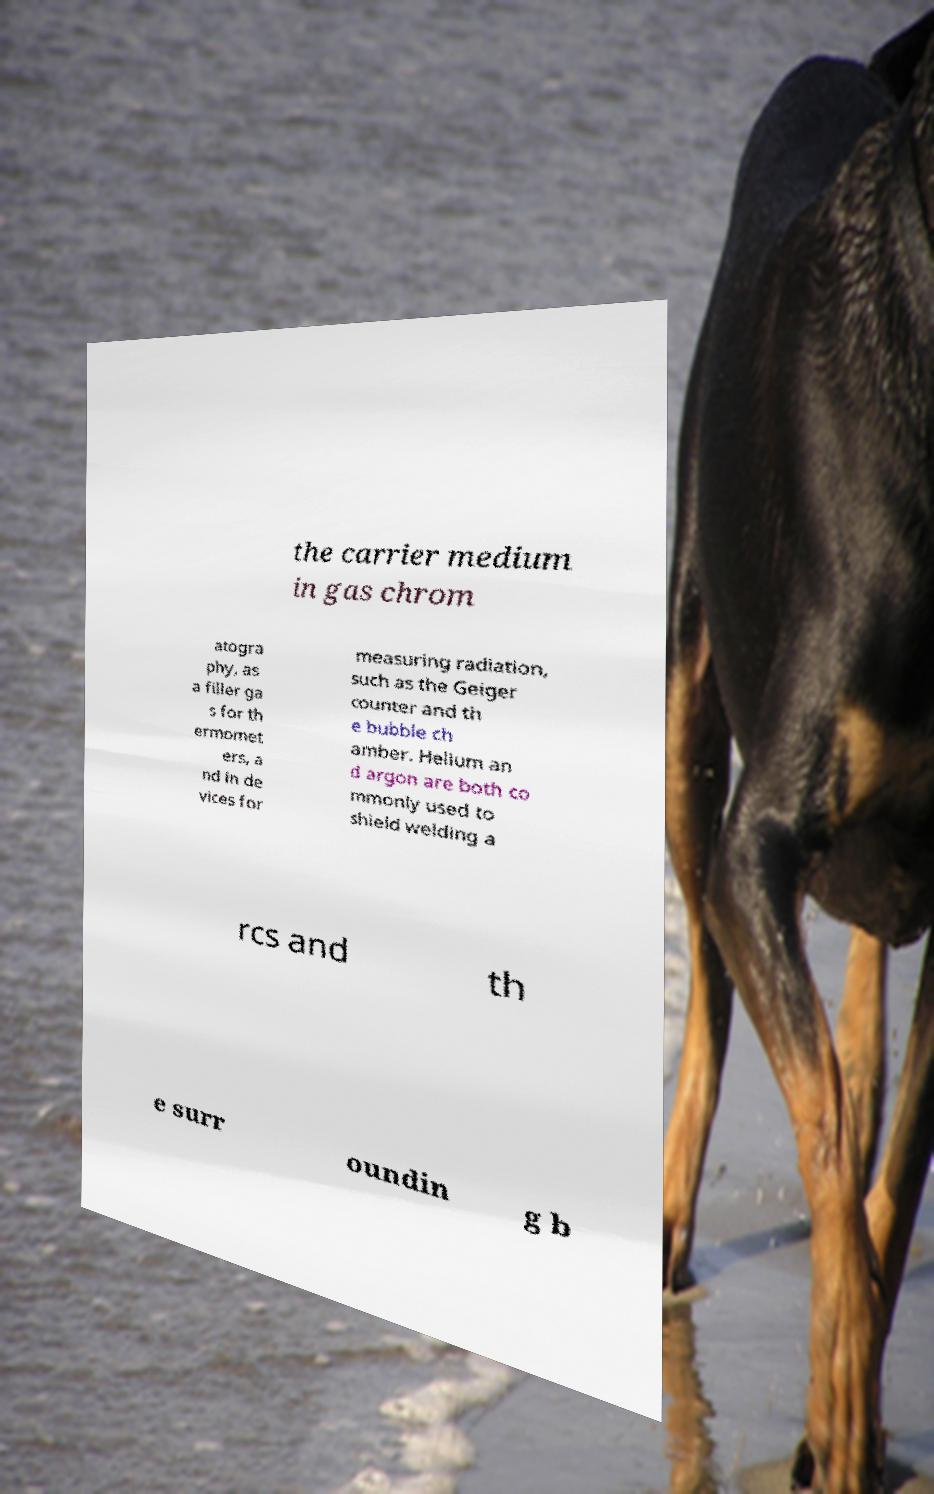There's text embedded in this image that I need extracted. Can you transcribe it verbatim? the carrier medium in gas chrom atogra phy, as a filler ga s for th ermomet ers, a nd in de vices for measuring radiation, such as the Geiger counter and th e bubble ch amber. Helium an d argon are both co mmonly used to shield welding a rcs and th e surr oundin g b 